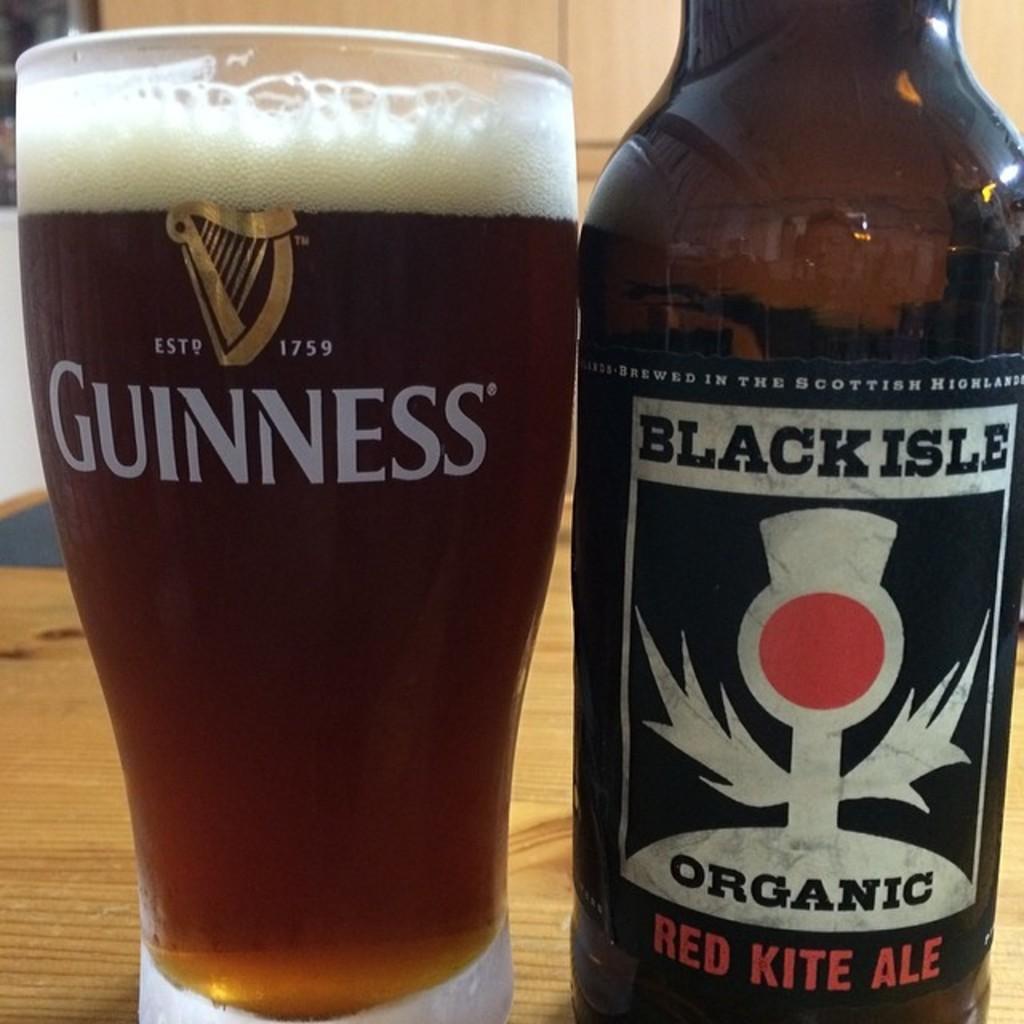In one or two sentences, can you explain what this image depicts? In this picture we can see a bottle and glass with full of drink in it on the table. 